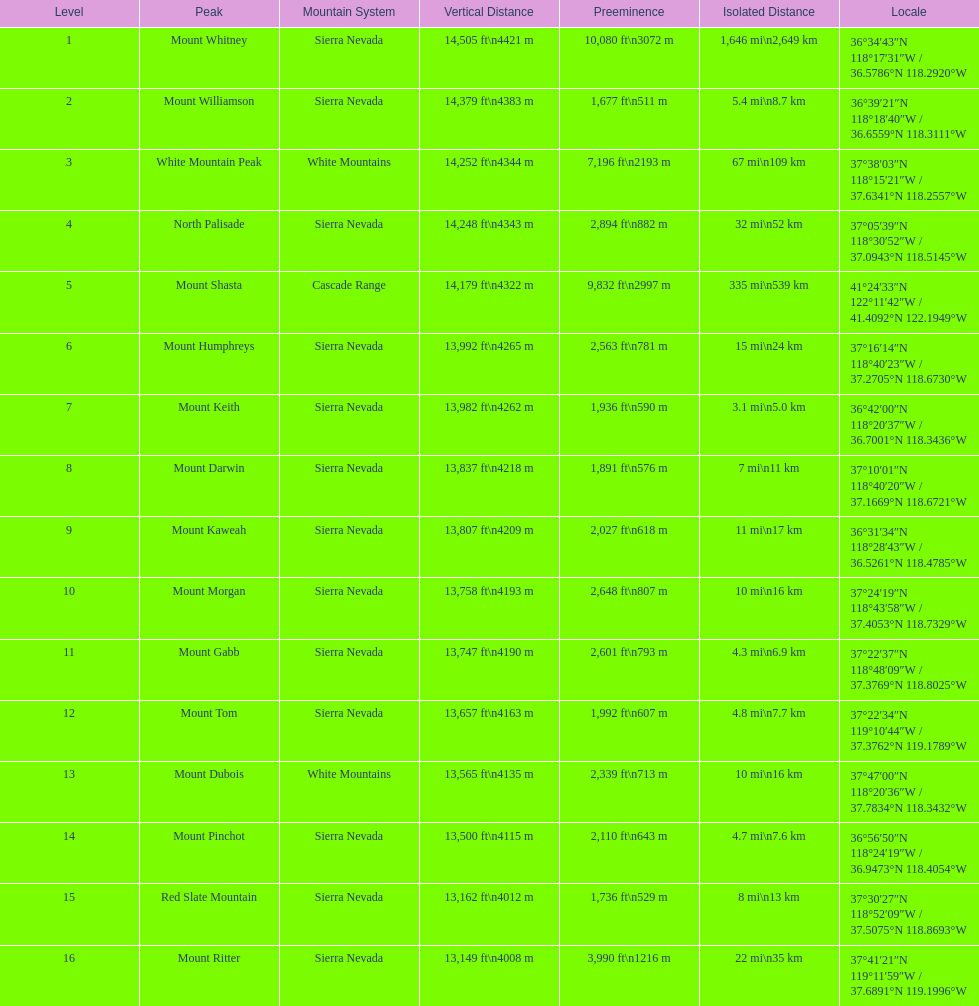Which mountain summit has the lowest isolation? Mount Keith. 